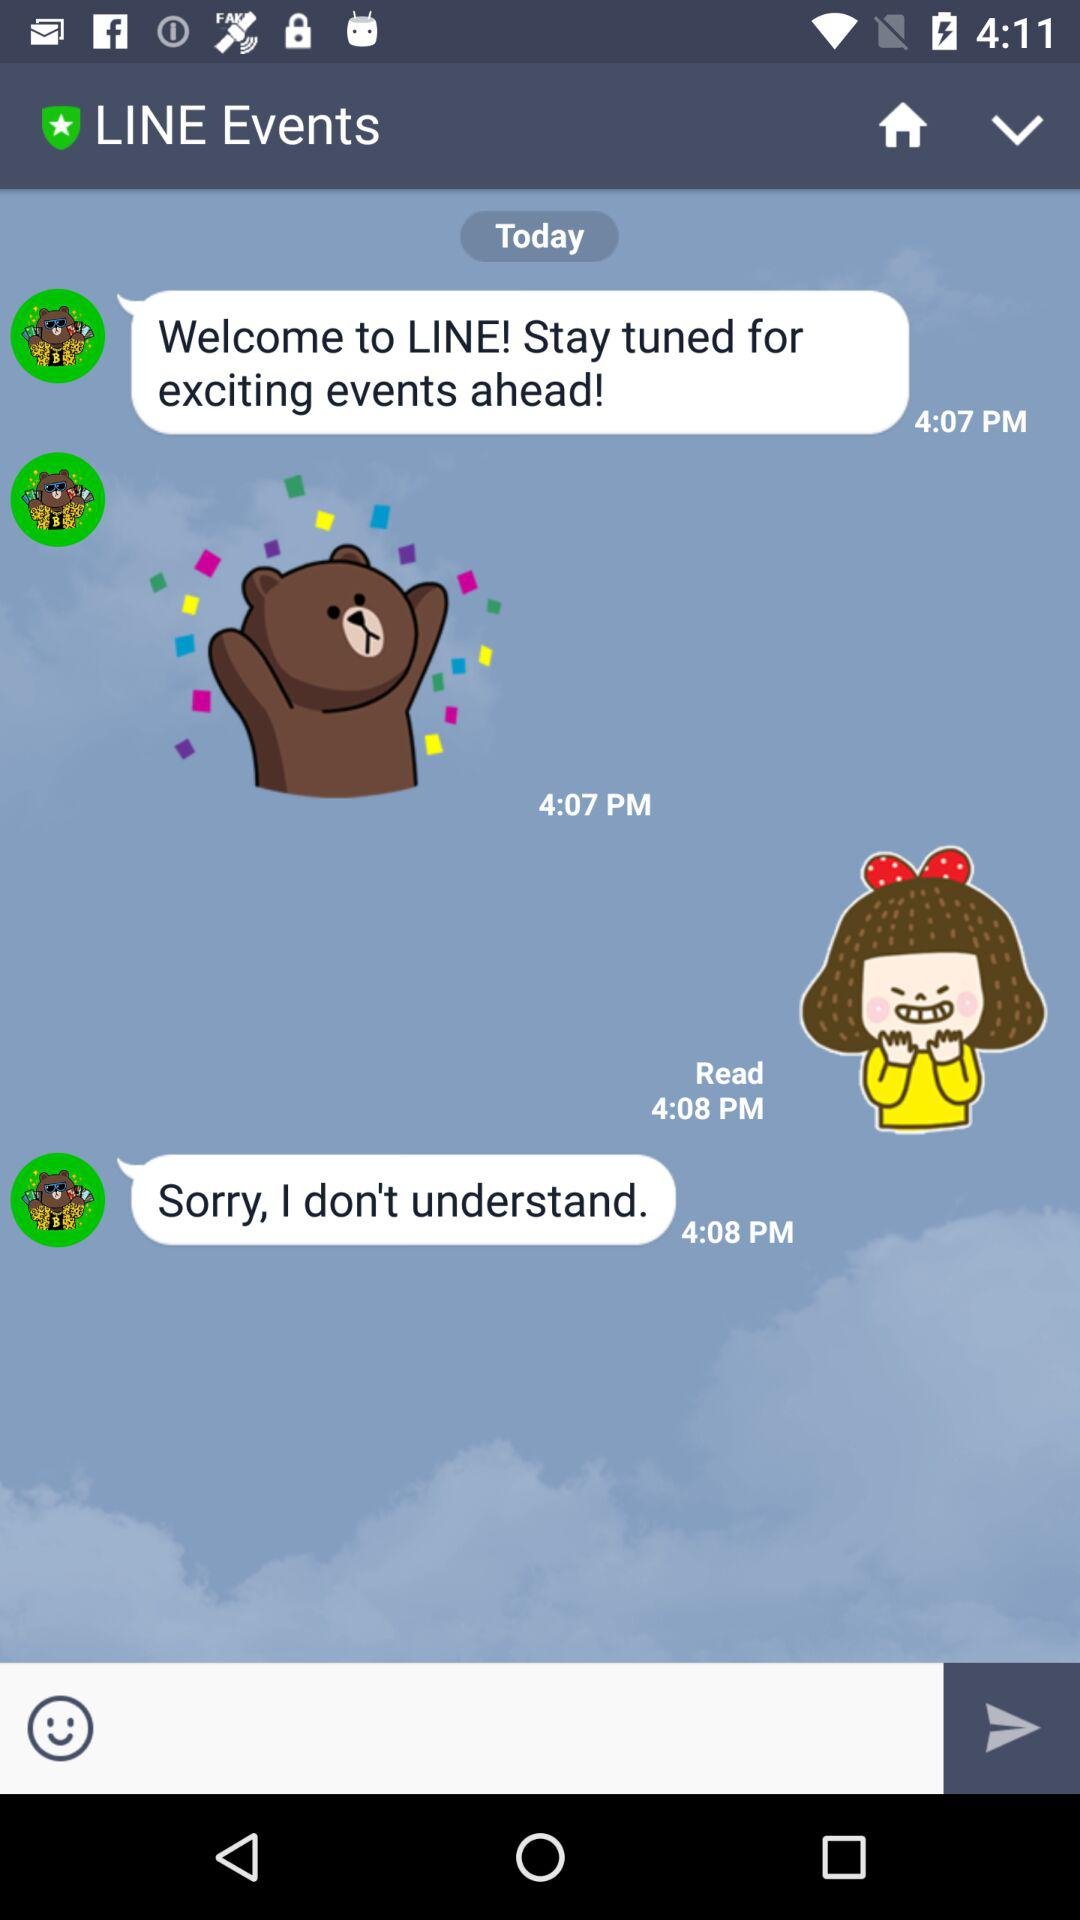What is the application name? The application name is "LINE". 